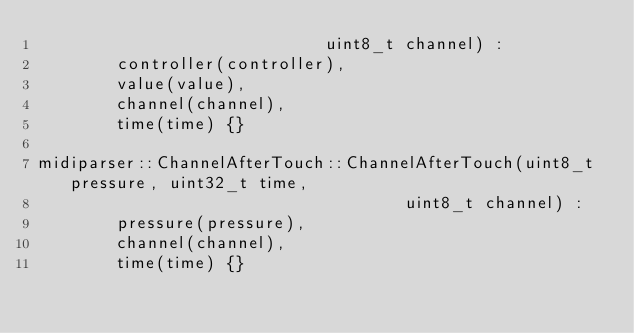<code> <loc_0><loc_0><loc_500><loc_500><_C++_>                             uint8_t channel) :
        controller(controller),
        value(value),
        channel(channel),
        time(time) {}

midiparser::ChannelAfterTouch::ChannelAfterTouch(uint8_t pressure, uint32_t time,
                                     uint8_t channel) :
        pressure(pressure),
        channel(channel),
        time(time) {}

</code> 